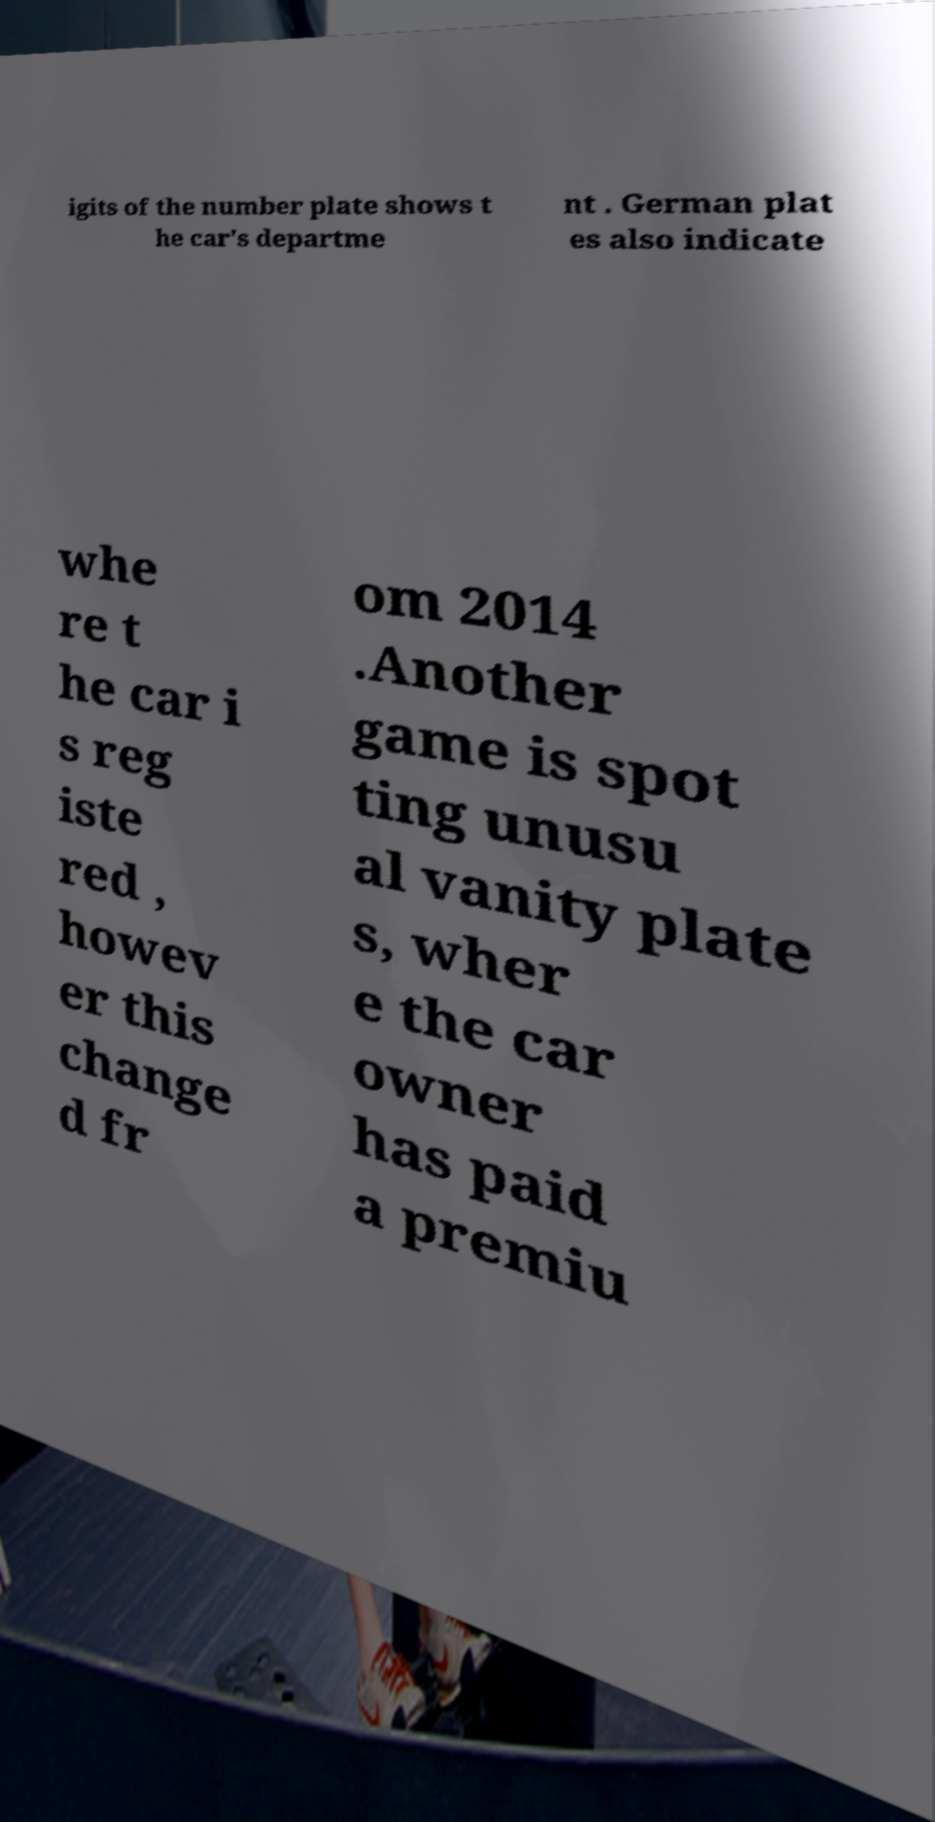There's text embedded in this image that I need extracted. Can you transcribe it verbatim? igits of the number plate shows t he car's departme nt . German plat es also indicate whe re t he car i s reg iste red , howev er this change d fr om 2014 .Another game is spot ting unusu al vanity plate s, wher e the car owner has paid a premiu 